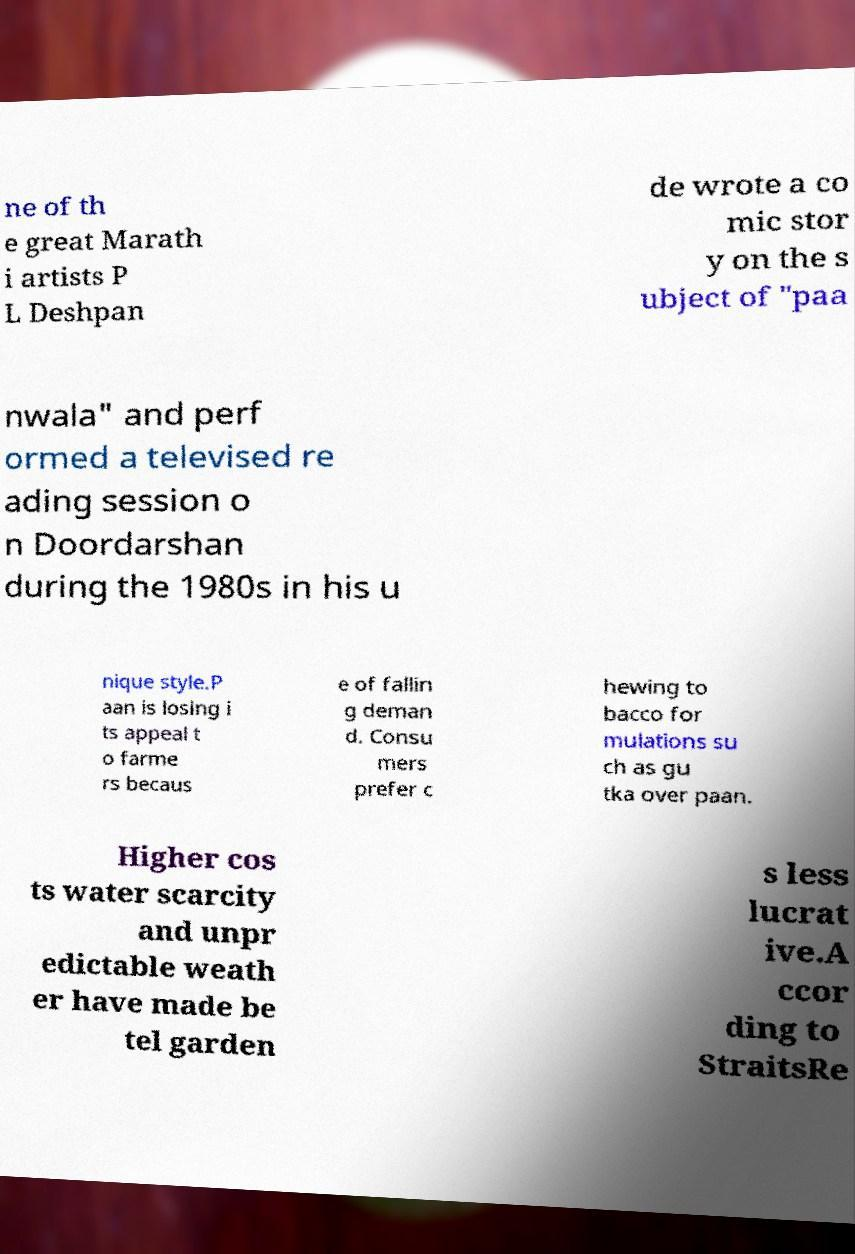Please identify and transcribe the text found in this image. ne of th e great Marath i artists P L Deshpan de wrote a co mic stor y on the s ubject of "paa nwala" and perf ormed a televised re ading session o n Doordarshan during the 1980s in his u nique style.P aan is losing i ts appeal t o farme rs becaus e of fallin g deman d. Consu mers prefer c hewing to bacco for mulations su ch as gu tka over paan. Higher cos ts water scarcity and unpr edictable weath er have made be tel garden s less lucrat ive.A ccor ding to StraitsRe 